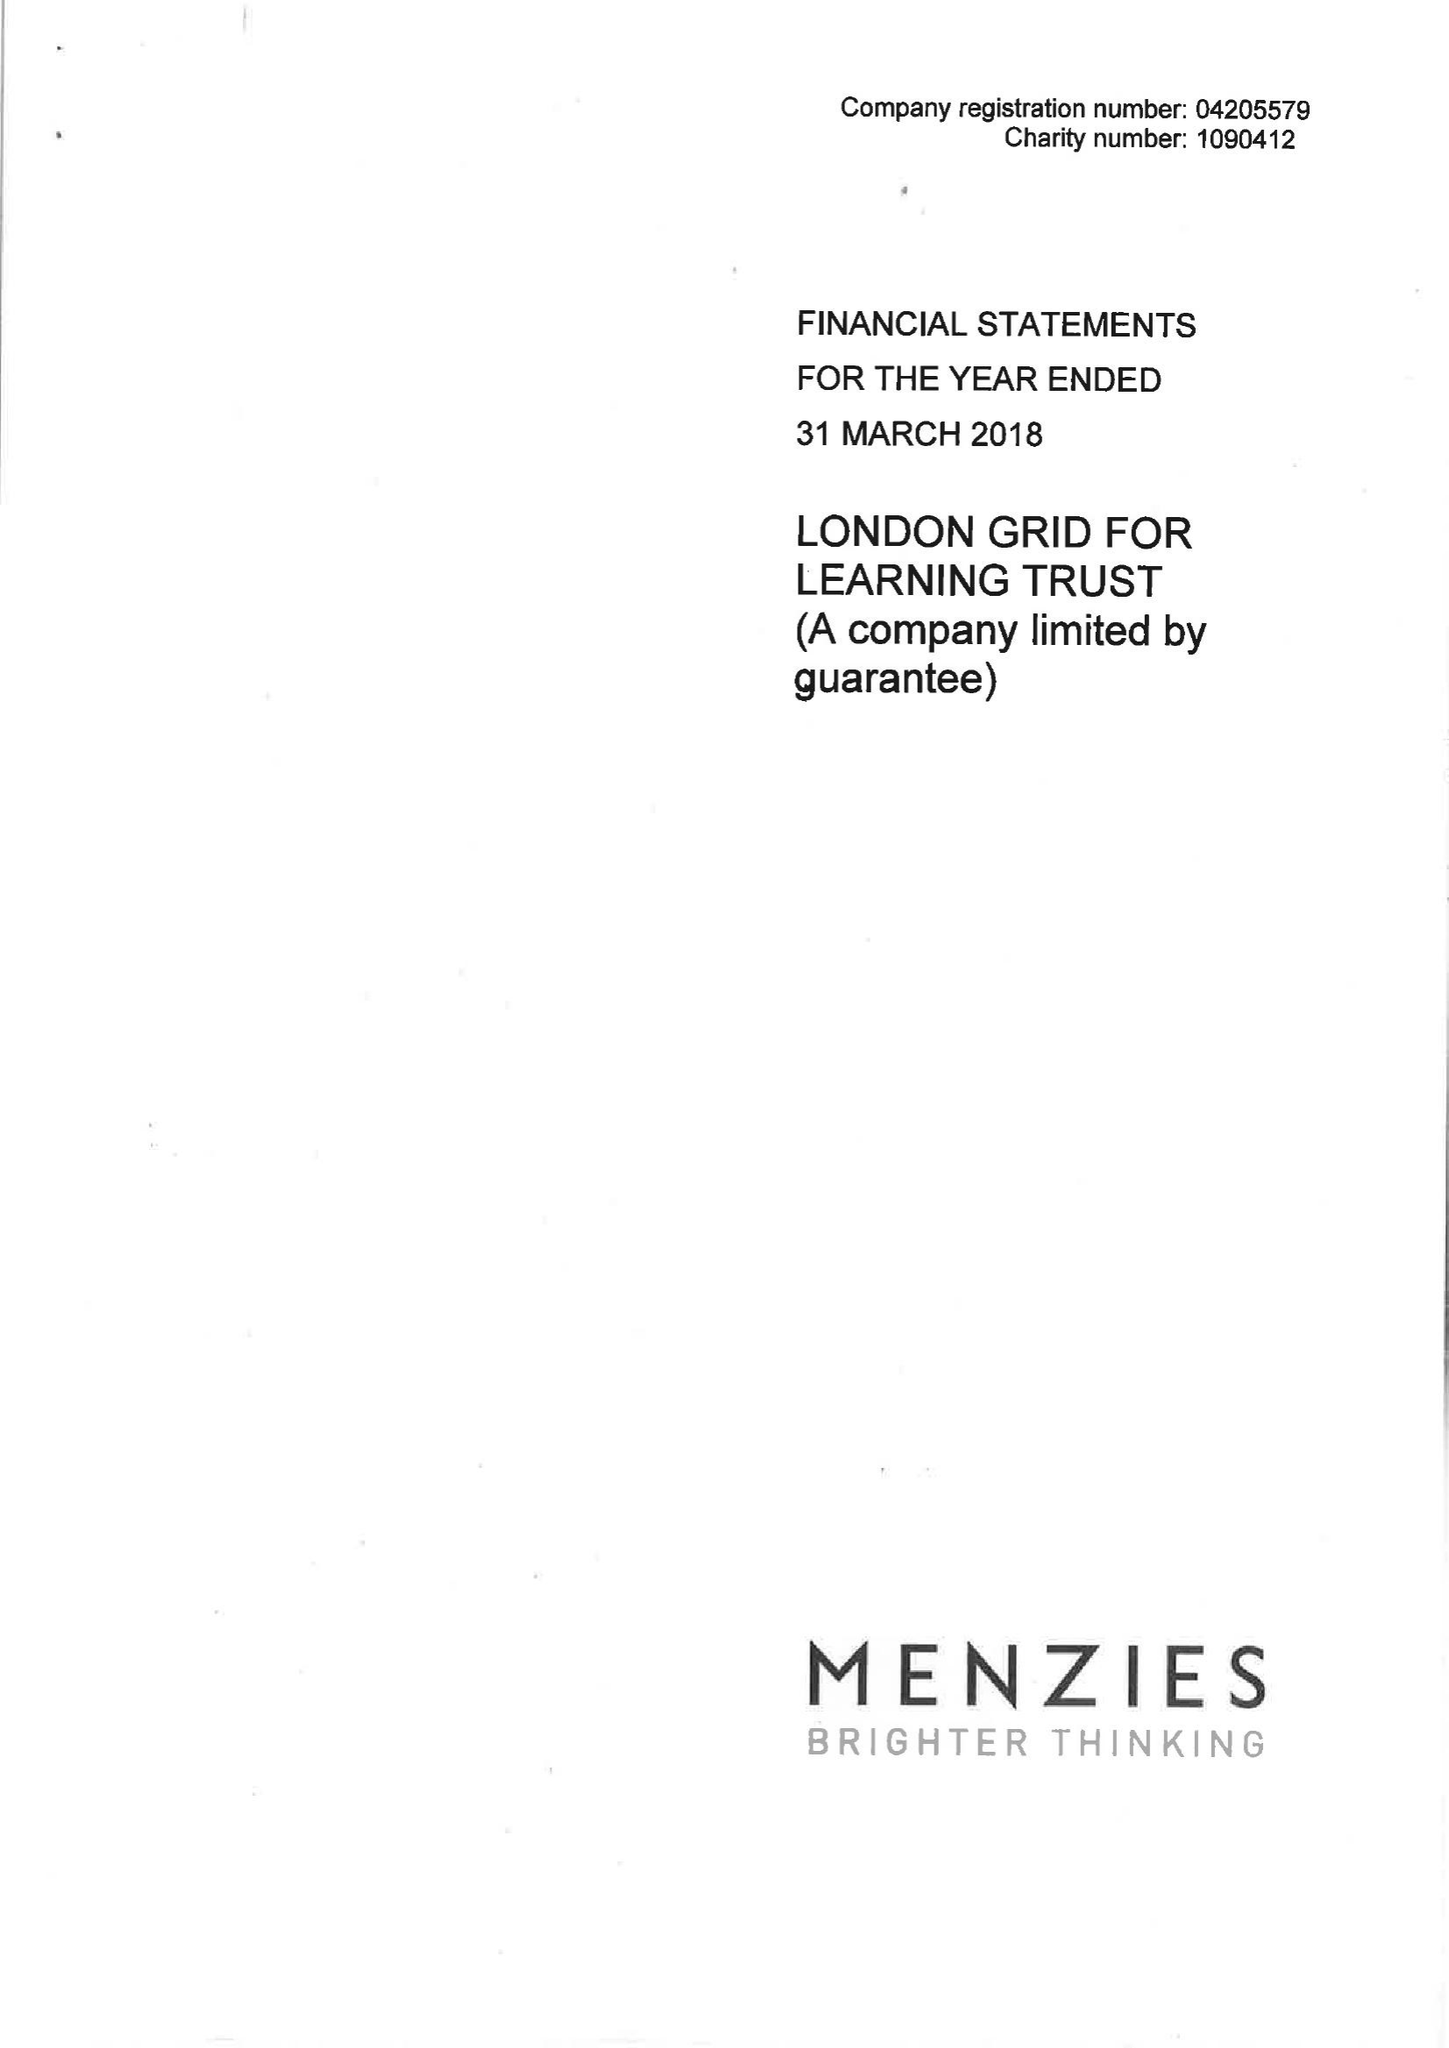What is the value for the income_annually_in_british_pounds?
Answer the question using a single word or phrase. 26938000.00 